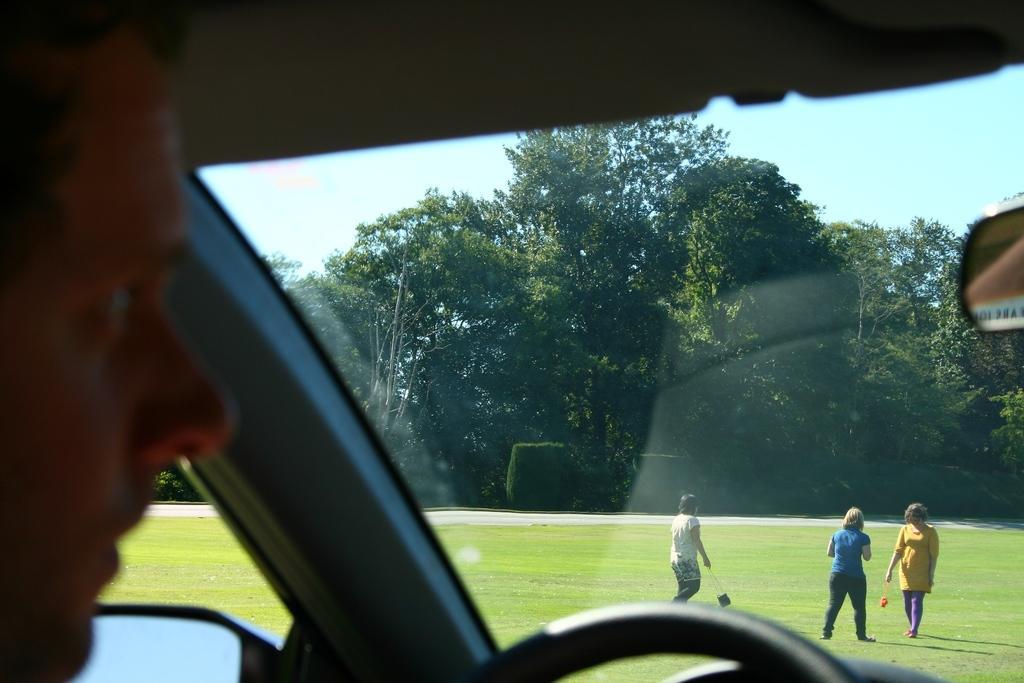Describe this image in one or two sentences. In this picture we can see a person in a vehicle. At the bottom of the image, there is a steering. On the right side of the image, there is a mirror. In front of the person, there is a glass. Behind the glass, there are trees, people, grass and the sky. 